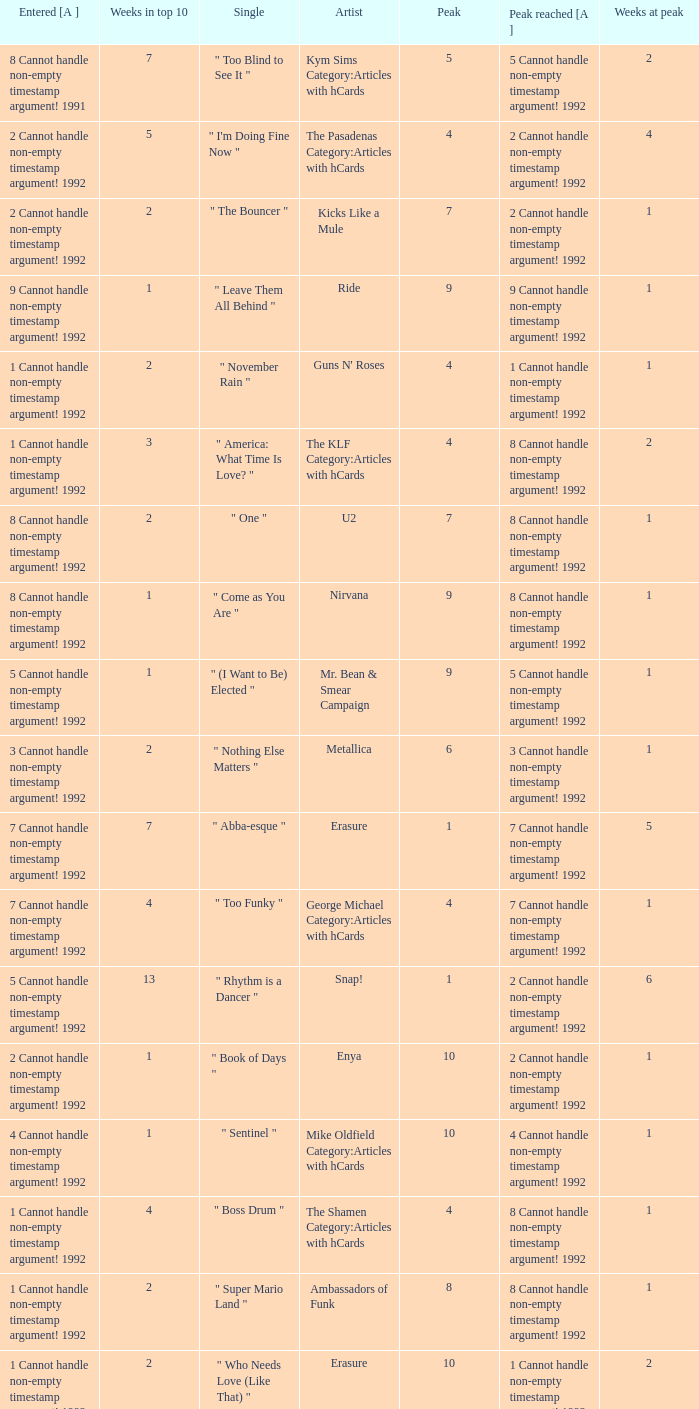What was the peak reached for a single with 4 weeks in the top 10 and entered in 7 cannot handle non-empty timestamp argument! 1992? 7 Cannot handle non-empty timestamp argument! 1992. 